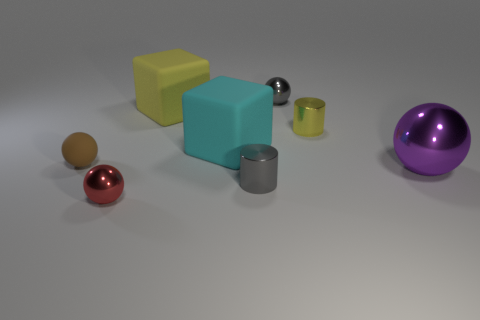Subtract all red balls. How many balls are left? 3 Subtract 1 cylinders. How many cylinders are left? 1 Add 2 small metal cylinders. How many objects exist? 10 Subtract 1 red spheres. How many objects are left? 7 Subtract all cylinders. How many objects are left? 6 Subtract all green cubes. Subtract all yellow cylinders. How many cubes are left? 2 Subtract all blue cylinders. How many cyan spheres are left? 0 Subtract all purple spheres. Subtract all small yellow rubber things. How many objects are left? 7 Add 5 big purple objects. How many big purple objects are left? 6 Add 3 large yellow rubber things. How many large yellow rubber things exist? 4 